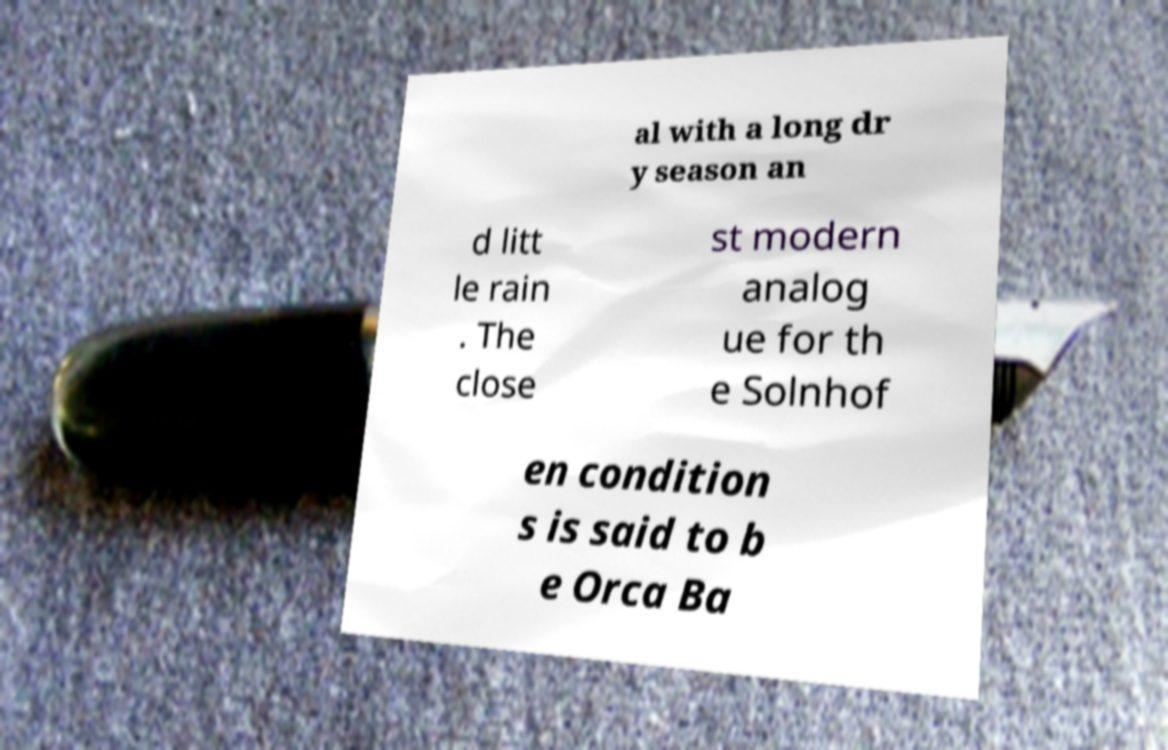Could you extract and type out the text from this image? al with a long dr y season an d litt le rain . The close st modern analog ue for th e Solnhof en condition s is said to b e Orca Ba 